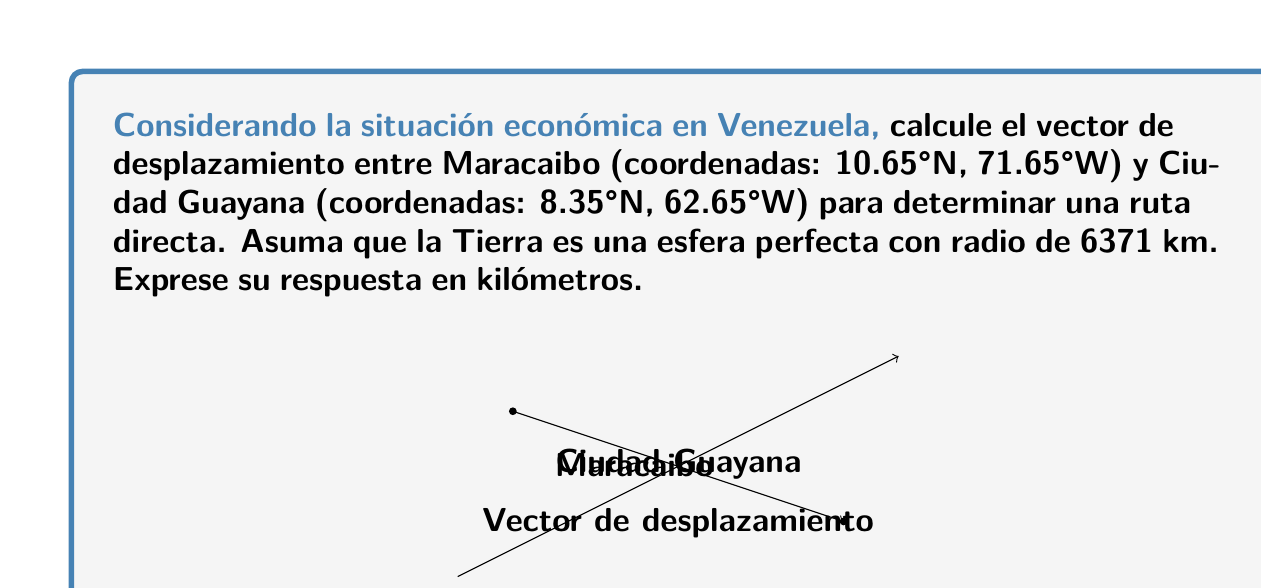What is the answer to this math problem? Para resolver este problema, seguiremos estos pasos:

1) Convertir las coordenadas a radianes:
   Maracaibo: $\phi_1 = 10.65° \cdot \frac{\pi}{180} = 0.1859$ rad, $\lambda_1 = -71.65° \cdot \frac{\pi}{180} = -1.2504$ rad
   Ciudad Guayana: $\phi_2 = 8.35° \cdot \frac{\pi}{180} = 0.1457$ rad, $\lambda_2 = -62.65° \cdot \frac{\pi}{180} = -1.0936$ rad

2) Calcular la diferencia en longitud:
   $\Delta \lambda = \lambda_2 - \lambda_1 = -1.0936 - (-1.2504) = 0.1568$ rad

3) Calcular el ángulo central $\theta$ usando la fórmula de Haversine:
   $$\theta = 2 \arcsin(\sqrt{\sin^2(\frac{\phi_2-\phi_1}{2}) + \cos(\phi_1)\cos(\phi_2)\sin^2(\frac{\Delta \lambda}{2})})$$
   
   $$\theta = 2 \arcsin(\sqrt{\sin^2(\frac{0.1457-0.1859}{2}) + \cos(0.1859)\cos(0.1457)\sin^2(\frac{0.1568}{2})})$$
   
   $$\theta = 0.1646$$ rad

4) Calcular la distancia sobre la superficie de la Tierra:
   $d = R\theta = 6371 \cdot 0.1646 = 1048.67$ km

5) Para obtener el vector de desplazamiento, necesitamos las componentes x, y, z:
   $$x = R(\cos(\phi_2)\cos(\lambda_2) - \cos(\phi_1)\cos(\lambda_1))$$
   $$y = R(\cos(\phi_2)\sin(\lambda_2) - \cos(\phi_1)\sin(\lambda_1))$$
   $$z = R(\sin(\phi_2) - \sin(\phi_1))$$

   Sustituyendo los valores:
   $x = 6371(0.9873 \cdot 0.4604 - 0.9828 \cdot 0.3145) = 816.32$ km
   $y = 6371(0.9873 \cdot (-0.8877) - 0.9828 \cdot (-0.9493)) = 655.89$ km
   $z = 6371(0.1452 - 0.1850) = -253.47$ km

6) El vector de desplazamiento es entonces $\vec{v} = (816.32, 655.89, -253.47)$ km
Answer: $\vec{v} = (816.32, 655.89, -253.47)$ km 